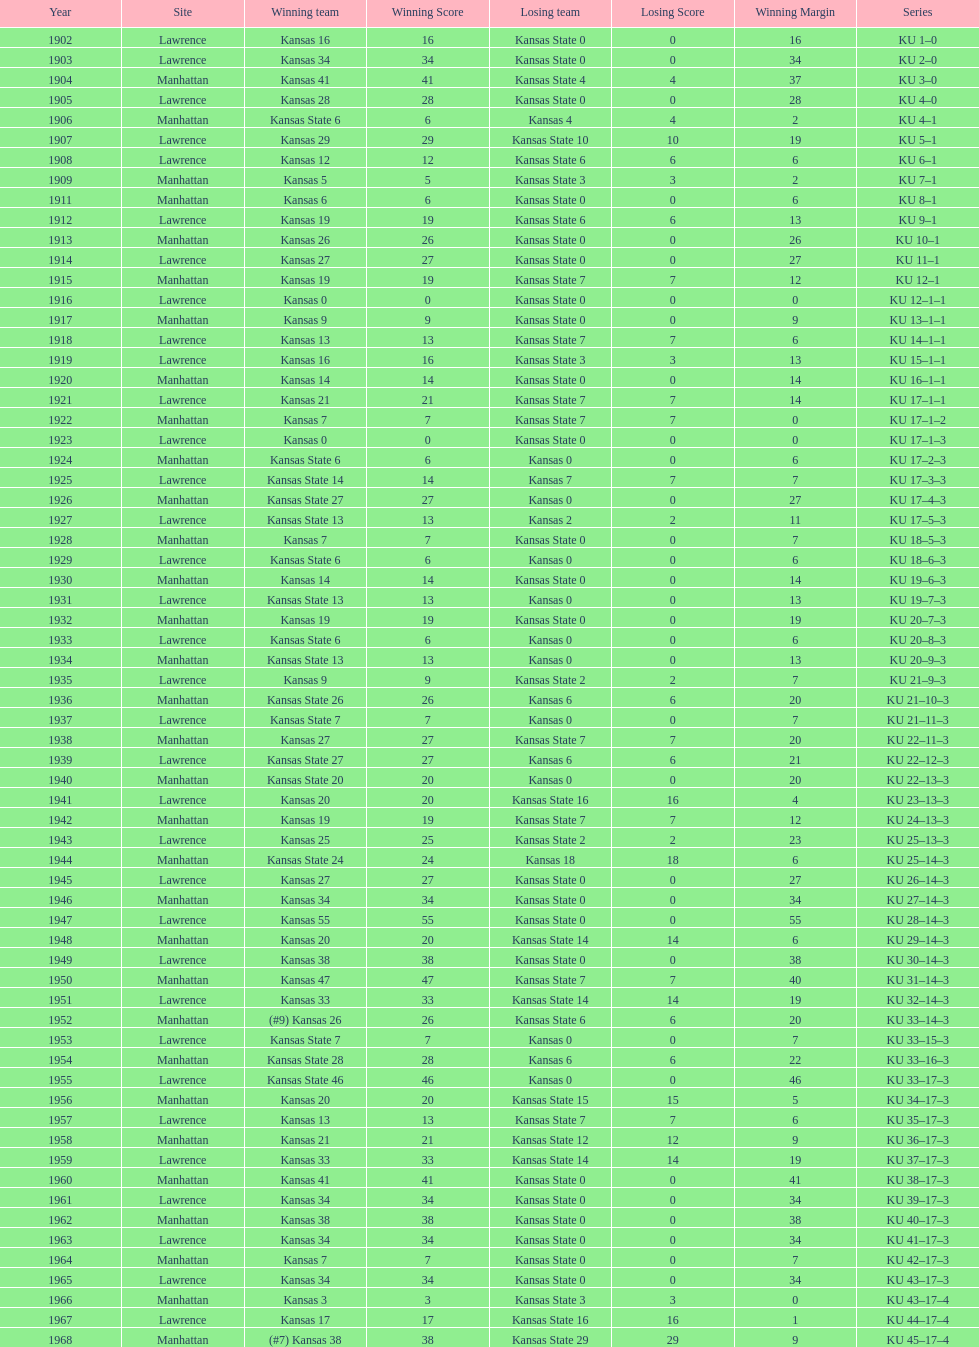What was the number of wins kansas state had in manhattan? 8. 